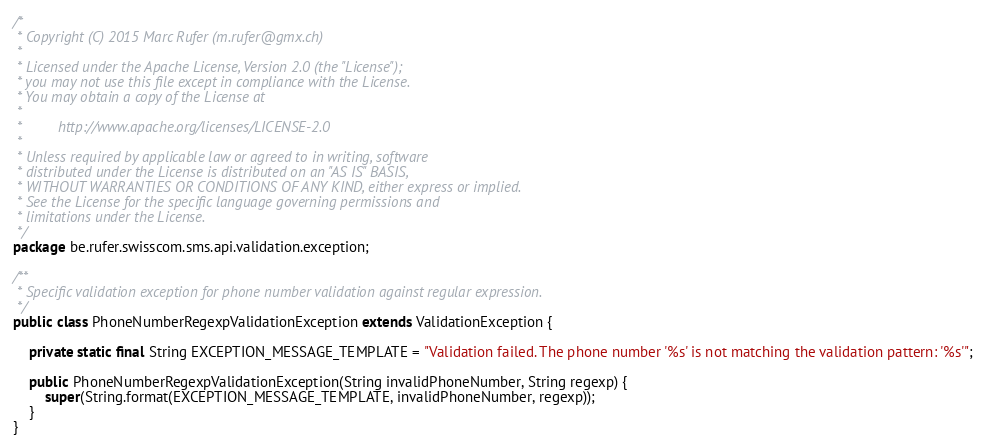<code> <loc_0><loc_0><loc_500><loc_500><_Java_>/*
 * Copyright (C) 2015 Marc Rufer (m.rufer@gmx.ch)
 *
 * Licensed under the Apache License, Version 2.0 (the "License");
 * you may not use this file except in compliance with the License.
 * You may obtain a copy of the License at
 *
 *         http://www.apache.org/licenses/LICENSE-2.0
 *
 * Unless required by applicable law or agreed to in writing, software
 * distributed under the License is distributed on an "AS IS" BASIS,
 * WITHOUT WARRANTIES OR CONDITIONS OF ANY KIND, either express or implied.
 * See the License for the specific language governing permissions and
 * limitations under the License.
 */
package be.rufer.swisscom.sms.api.validation.exception;

/**
 * Specific validation exception for phone number validation against regular expression.
 */
public class PhoneNumberRegexpValidationException extends ValidationException {

    private static final String EXCEPTION_MESSAGE_TEMPLATE = "Validation failed. The phone number '%s' is not matching the validation pattern: '%s'";

    public PhoneNumberRegexpValidationException(String invalidPhoneNumber, String regexp) {
        super(String.format(EXCEPTION_MESSAGE_TEMPLATE, invalidPhoneNumber, regexp));
    }
}
</code> 